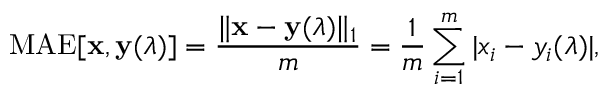<formula> <loc_0><loc_0><loc_500><loc_500>M A E [ x , y ( \lambda ) ] = \frac { \| x - y ( \lambda ) \| _ { 1 } } { m } = \frac { 1 } { m } \sum _ { i = 1 } ^ { m } | x _ { i } - y _ { i } ( \lambda ) | ,</formula> 